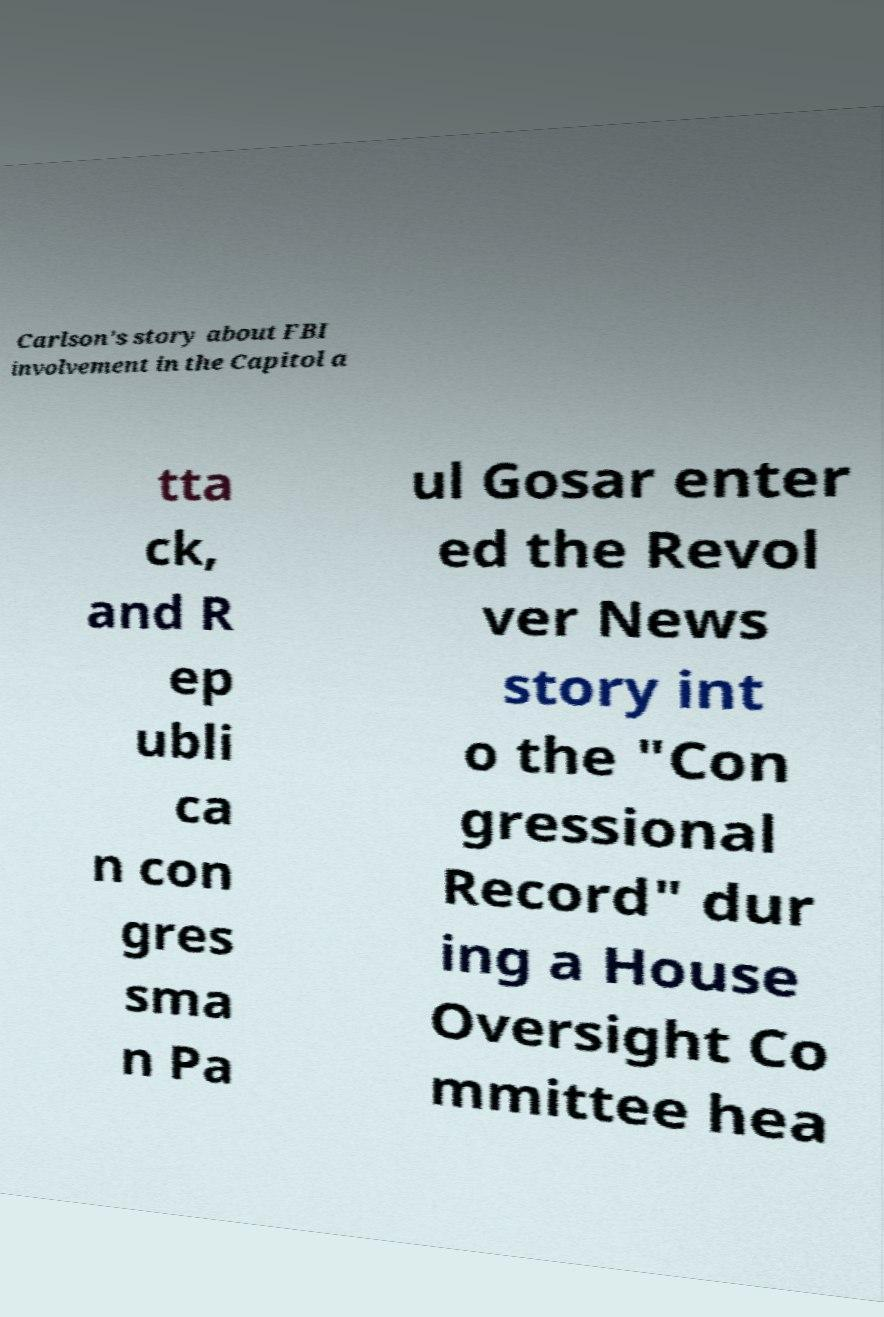Could you assist in decoding the text presented in this image and type it out clearly? Carlson's story about FBI involvement in the Capitol a tta ck, and R ep ubli ca n con gres sma n Pa ul Gosar enter ed the Revol ver News story int o the "Con gressional Record" dur ing a House Oversight Co mmittee hea 